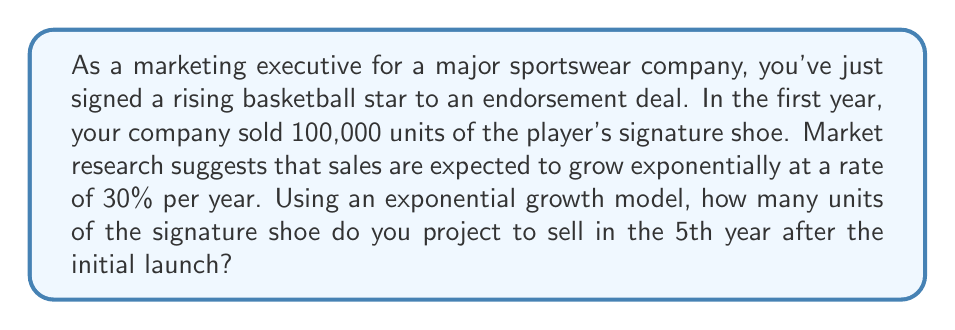Give your solution to this math problem. To solve this problem, we'll use the exponential growth model:

$$A = P(1 + r)^t$$

Where:
$A$ = Amount after growth
$P$ = Initial principal amount
$r$ = Growth rate (as a decimal)
$t$ = Time periods

Given:
$P = 100,000$ (initial sales)
$r = 0.30$ (30% growth rate)
$t = 5$ (5th year after launch)

Let's substitute these values into our equation:

$$A = 100,000(1 + 0.30)^5$$

Now, let's solve step-by-step:

1) First, calculate $(1 + 0.30)^5$:
   $$(1.30)^5 = 3.7129$$

2) Multiply this by the initial amount:
   $$100,000 \times 3.7129 = 371,290$$

Therefore, in the 5th year after the initial launch, we project to sell approximately 371,290 units of the signature shoe.
Answer: 371,290 units 